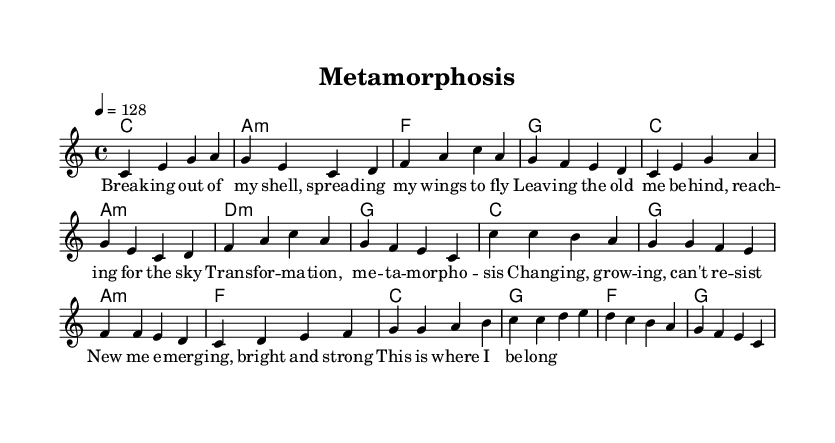What is the key signature of this music? The key signature is C major, which has no sharps or flats indicated in the global section of the code.
Answer: C major What is the time signature of the piece? The time signature is found in the global section where it states "4/4," which indicates four beats in a measure and a quarter note receives one beat.
Answer: 4/4 What is the tempo marking for the music? The tempo marking appears in the global section as "4 = 128," which indicates that the metronome should tick at 128 beats per minute with the note value of quarter note equating to one beat.
Answer: 128 How many measures are in the verse? The verse consists of two musical phrases, each containing four measures, totaling eight measures in the verse, as counted in the melody section specifically for the verse part.
Answer: 8 What is the main theme conveyed through the lyrics? The lyrics primarily express themes of transformation and change, as indicated by phrases like "Breaking out of my shell" and "Transformation, metamorphosis," emphasizing personal growth and new beginnings.
Answer: Transformation What type of harmonic progression is used in the chorus? The harmonic progression in the chorus includes common K-Pop elements, with chords such as C, G, and A minor creating a bright, uplifting feel characteristic of the genre, suggesting a progression of I - V - vi - IV.
Answer: I - V - vi - IV What is the structure of the song based on the provided sheet music? The structure includes a verse section followed by a chorus section, which is a common structure in K-Pop tracks where verses build emotion leading into an impactful and catchy chorus.
Answer: Verse - Chorus 